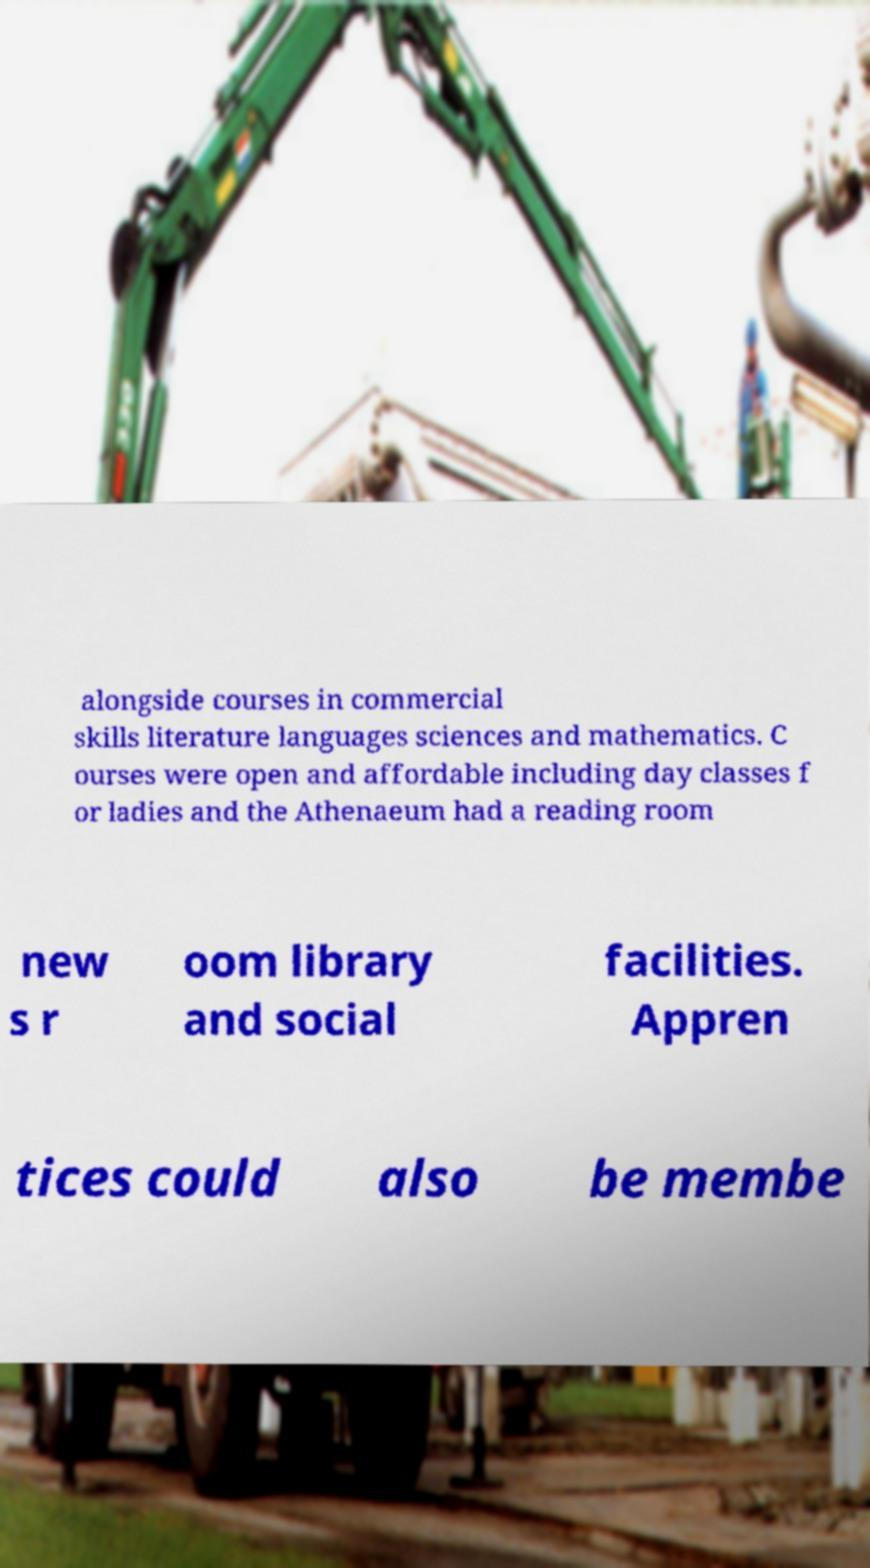For documentation purposes, I need the text within this image transcribed. Could you provide that? alongside courses in commercial skills literature languages sciences and mathematics. C ourses were open and affordable including day classes f or ladies and the Athenaeum had a reading room new s r oom library and social facilities. Appren tices could also be membe 